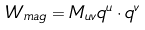<formula> <loc_0><loc_0><loc_500><loc_500>W _ { m a g } = M _ { u v } q ^ { u } \cdot q ^ { v }</formula> 